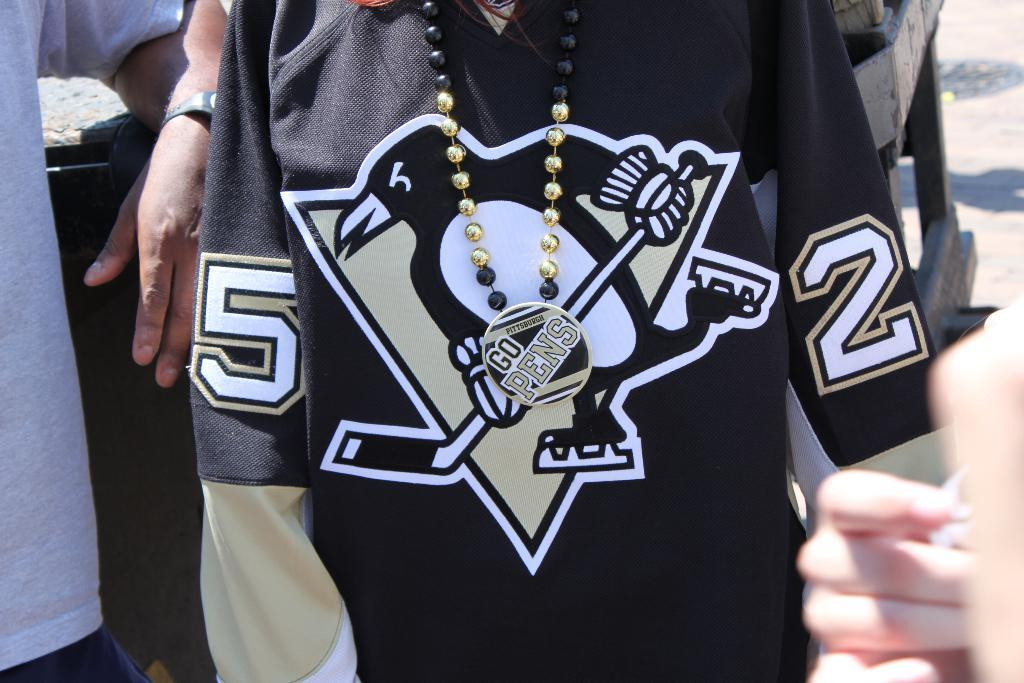<image>
Present a compact description of the photo's key features. A person is wearing a Pittsburgh Penguins hockey jersey and beaded necklace. 